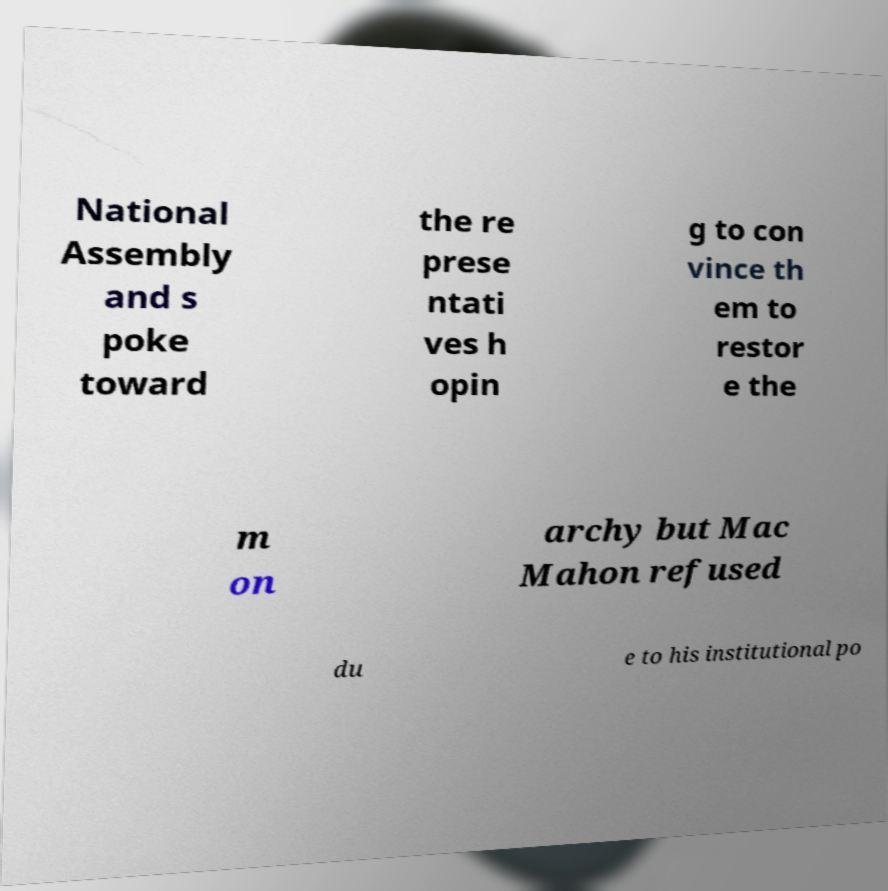Please read and relay the text visible in this image. What does it say? National Assembly and s poke toward the re prese ntati ves h opin g to con vince th em to restor e the m on archy but Mac Mahon refused du e to his institutional po 